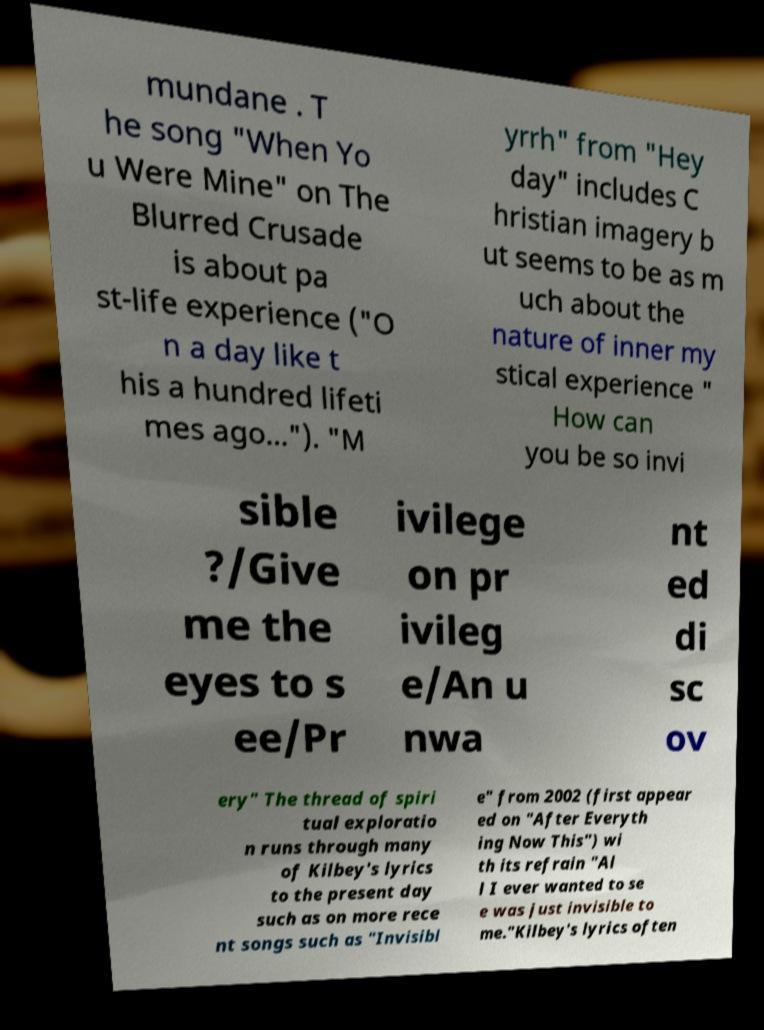Can you read and provide the text displayed in the image?This photo seems to have some interesting text. Can you extract and type it out for me? mundane . T he song "When Yo u Were Mine" on The Blurred Crusade is about pa st-life experience ("O n a day like t his a hundred lifeti mes ago..."). "M yrrh" from "Hey day" includes C hristian imagery b ut seems to be as m uch about the nature of inner my stical experience " How can you be so invi sible ?/Give me the eyes to s ee/Pr ivilege on pr ivileg e/An u nwa nt ed di sc ov ery" The thread of spiri tual exploratio n runs through many of Kilbey's lyrics to the present day such as on more rece nt songs such as "Invisibl e" from 2002 (first appear ed on "After Everyth ing Now This") wi th its refrain "Al l I ever wanted to se e was just invisible to me."Kilbey's lyrics often 